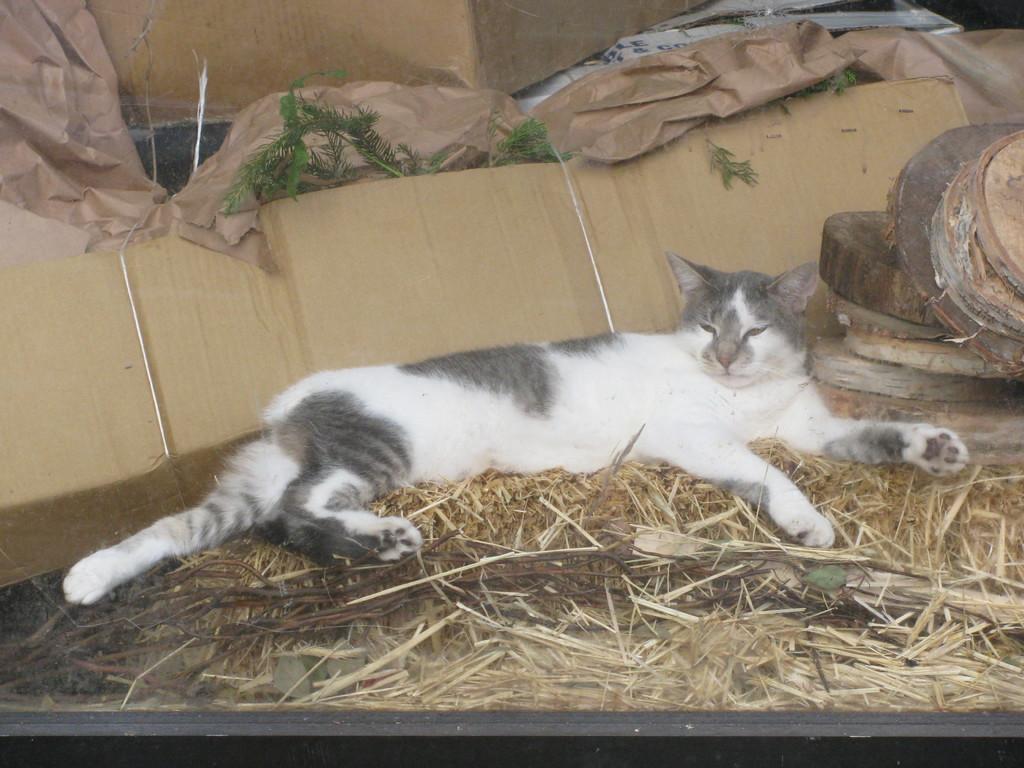In one or two sentences, can you explain what this image depicts? In the image we can see there is a cat lying on the ground and there is dry grass on the ground. Behind there is a cardboard sheet and there are round wooden logs kept on the ground. 